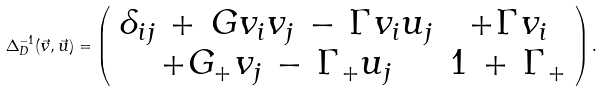Convert formula to latex. <formula><loc_0><loc_0><loc_500><loc_500>\Delta _ { D } ^ { - 1 } ( \vec { v } , \vec { u } ) = \left ( \begin{array} { c c } \delta _ { i j } \, + \, G v _ { i } v _ { j } \, - \, \Gamma v _ { i } u _ { j } & + \Gamma v _ { i } \\ + G _ { + } v _ { j } \, - \, \Gamma _ { + } u _ { j } & 1 \, + \, \Gamma _ { + } \\ \end{array} \right ) .</formula> 